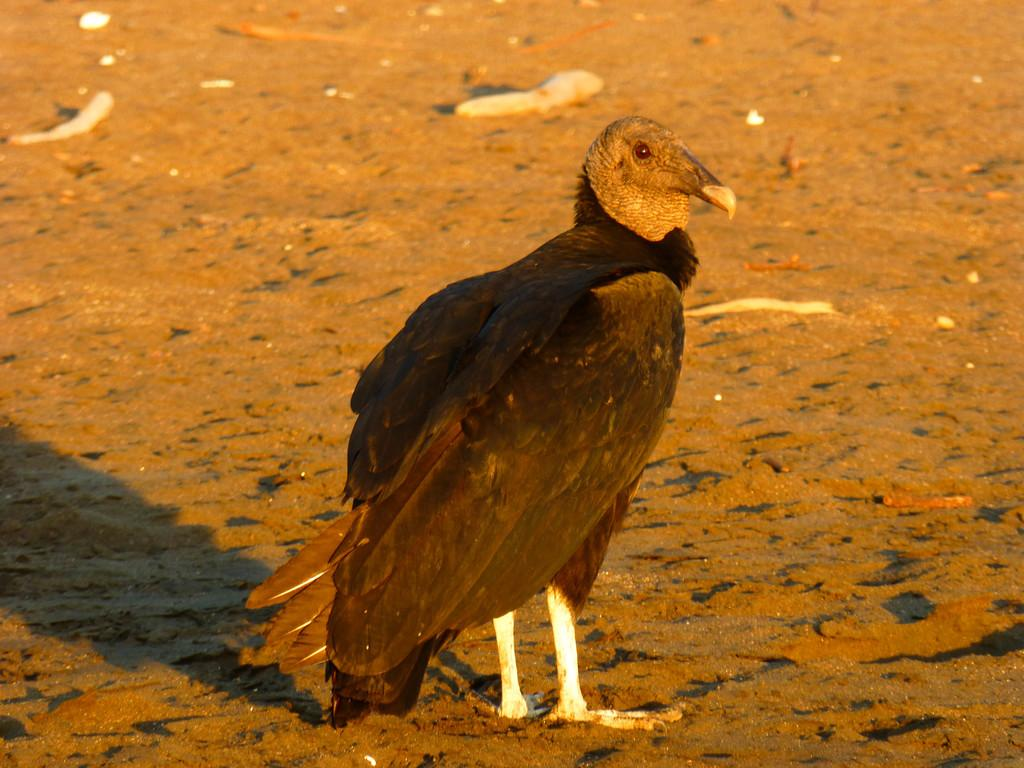What type of animal can be seen in the image? There is a bird in the image. Where is the bird located in the image? The bird is on the ground in the image. What is the color of the bird? The bird is brown in color. Can you describe the bird's features? The bird has an eye and feathers. What type of family does the robin belong to in the image? There is no robin present in the image, and therefore no family can be identified. What is the zephyr's role in the image? There is no zephyr mentioned or present in the image. 